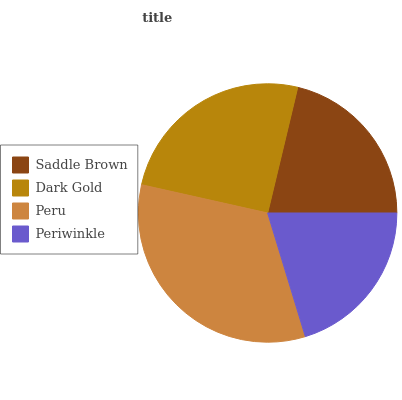Is Periwinkle the minimum?
Answer yes or no. Yes. Is Peru the maximum?
Answer yes or no. Yes. Is Dark Gold the minimum?
Answer yes or no. No. Is Dark Gold the maximum?
Answer yes or no. No. Is Dark Gold greater than Saddle Brown?
Answer yes or no. Yes. Is Saddle Brown less than Dark Gold?
Answer yes or no. Yes. Is Saddle Brown greater than Dark Gold?
Answer yes or no. No. Is Dark Gold less than Saddle Brown?
Answer yes or no. No. Is Dark Gold the high median?
Answer yes or no. Yes. Is Saddle Brown the low median?
Answer yes or no. Yes. Is Saddle Brown the high median?
Answer yes or no. No. Is Peru the low median?
Answer yes or no. No. 